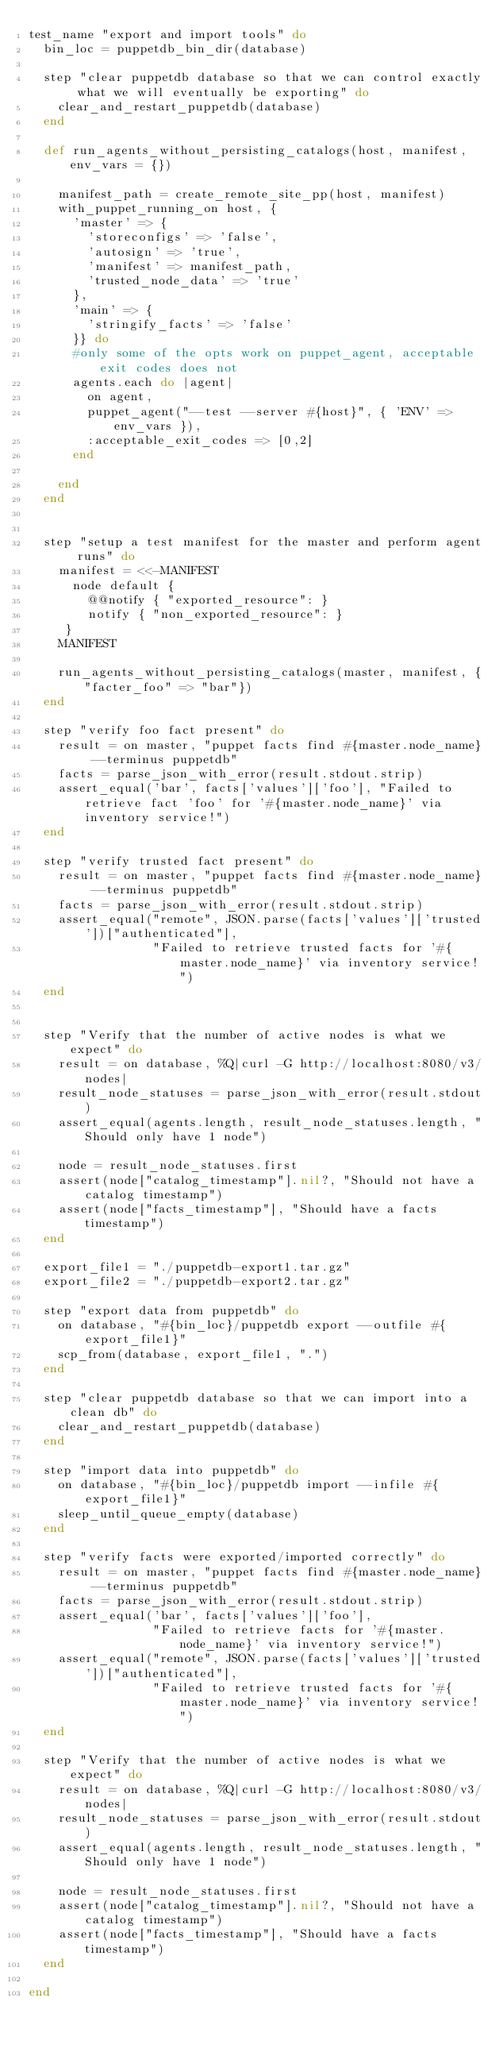Convert code to text. <code><loc_0><loc_0><loc_500><loc_500><_Ruby_>test_name "export and import tools" do
  bin_loc = puppetdb_bin_dir(database)

  step "clear puppetdb database so that we can control exactly what we will eventually be exporting" do
    clear_and_restart_puppetdb(database)
  end

  def run_agents_without_persisting_catalogs(host, manifest, env_vars = {})

    manifest_path = create_remote_site_pp(host, manifest)
    with_puppet_running_on host, {
      'master' => {
        'storeconfigs' => 'false',
        'autosign' => 'true',
        'manifest' => manifest_path,
        'trusted_node_data' => 'true'
      },
      'main' => {
        'stringify_facts' => 'false'
      }} do
      #only some of the opts work on puppet_agent, acceptable exit codes does not
      agents.each do |agent|
        on agent,
        puppet_agent("--test --server #{host}", { 'ENV' => env_vars }),
        :acceptable_exit_codes => [0,2]
      end

    end
  end


  step "setup a test manifest for the master and perform agent runs" do
    manifest = <<-MANIFEST
      node default {
        @@notify { "exported_resource": }
        notify { "non_exported_resource": }
     }
    MANIFEST

    run_agents_without_persisting_catalogs(master, manifest, {"facter_foo" => "bar"})
  end

  step "verify foo fact present" do
    result = on master, "puppet facts find #{master.node_name} --terminus puppetdb"
    facts = parse_json_with_error(result.stdout.strip)
    assert_equal('bar', facts['values']['foo'], "Failed to retrieve fact 'foo' for '#{master.node_name}' via inventory service!")
  end

  step "verify trusted fact present" do
    result = on master, "puppet facts find #{master.node_name} --terminus puppetdb"
    facts = parse_json_with_error(result.stdout.strip)
    assert_equal("remote", JSON.parse(facts['values']['trusted'])["authenticated"],
                 "Failed to retrieve trusted facts for '#{master.node_name}' via inventory service!")
  end


  step "Verify that the number of active nodes is what we expect" do
    result = on database, %Q|curl -G http://localhost:8080/v3/nodes|
    result_node_statuses = parse_json_with_error(result.stdout)
    assert_equal(agents.length, result_node_statuses.length, "Should only have 1 node")

    node = result_node_statuses.first
    assert(node["catalog_timestamp"].nil?, "Should not have a catalog timestamp")
    assert(node["facts_timestamp"], "Should have a facts timestamp")
  end

  export_file1 = "./puppetdb-export1.tar.gz"
  export_file2 = "./puppetdb-export2.tar.gz"

  step "export data from puppetdb" do
    on database, "#{bin_loc}/puppetdb export --outfile #{export_file1}"
    scp_from(database, export_file1, ".")
  end

  step "clear puppetdb database so that we can import into a clean db" do
    clear_and_restart_puppetdb(database)
  end

  step "import data into puppetdb" do
    on database, "#{bin_loc}/puppetdb import --infile #{export_file1}"
    sleep_until_queue_empty(database)
  end

  step "verify facts were exported/imported correctly" do
    result = on master, "puppet facts find #{master.node_name} --terminus puppetdb"
    facts = parse_json_with_error(result.stdout.strip)
    assert_equal('bar', facts['values']['foo'],
                 "Failed to retrieve facts for '#{master.node_name}' via inventory service!")
    assert_equal("remote", JSON.parse(facts['values']['trusted'])["authenticated"],
                 "Failed to retrieve trusted facts for '#{master.node_name}' via inventory service!")
  end

  step "Verify that the number of active nodes is what we expect" do
    result = on database, %Q|curl -G http://localhost:8080/v3/nodes|
    result_node_statuses = parse_json_with_error(result.stdout)
    assert_equal(agents.length, result_node_statuses.length, "Should only have 1 node")

    node = result_node_statuses.first
    assert(node["catalog_timestamp"].nil?, "Should not have a catalog timestamp")
    assert(node["facts_timestamp"], "Should have a facts timestamp")
  end

end
</code> 